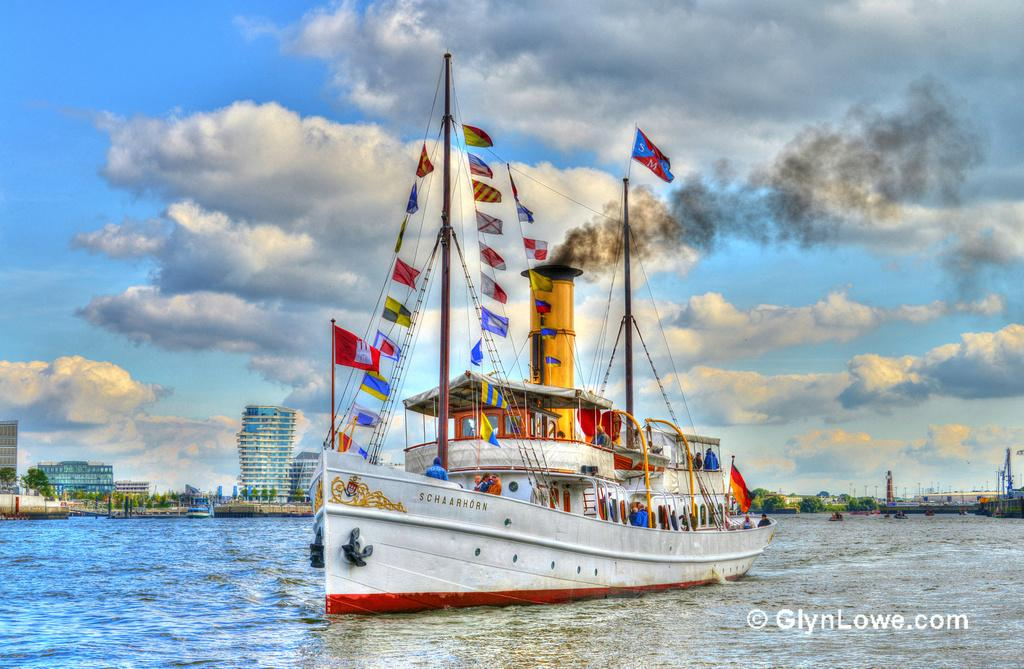What is the main subject of the image? There is a ship sailing on the water in the image. What can be seen in the background of the image? There are buildings and trees behind the ship. What type of calculator is being used by the uncle in the image? There is no calculator or uncle present in the image. What taste does the water have in the image? The taste of the water cannot be determined from the image, as taste is not a visual characteristic. 